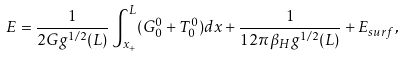Convert formula to latex. <formula><loc_0><loc_0><loc_500><loc_500>E = { \frac { 1 } { 2 G g ^ { 1 / 2 } ( L ) } } \int _ { x _ { + } } ^ { L } ( G _ { 0 } ^ { 0 } + T _ { 0 } ^ { 0 } ) d x + { \frac { 1 } { 1 2 \pi \beta _ { H } g ^ { 1 / 2 } ( L ) } } + E _ { s u r f } ,</formula> 